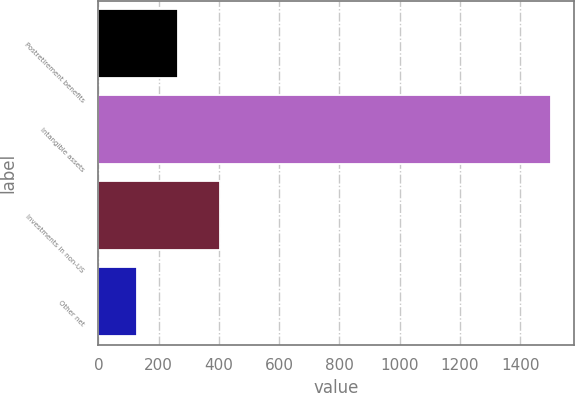Convert chart. <chart><loc_0><loc_0><loc_500><loc_500><bar_chart><fcel>Postretirement benefits<fcel>Intangible assets<fcel>Investments in non-US<fcel>Other net<nl><fcel>265.4<fcel>1502<fcel>402.8<fcel>128<nl></chart> 